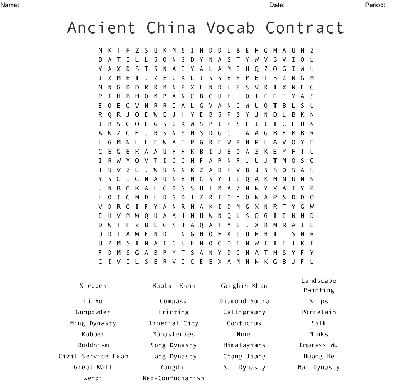What is the main theme of the word search? The main theme of the word search revolves around Ancient China, focusing on its rich history, significant cultural elements, and notable figures such as emperors and philosophers. 